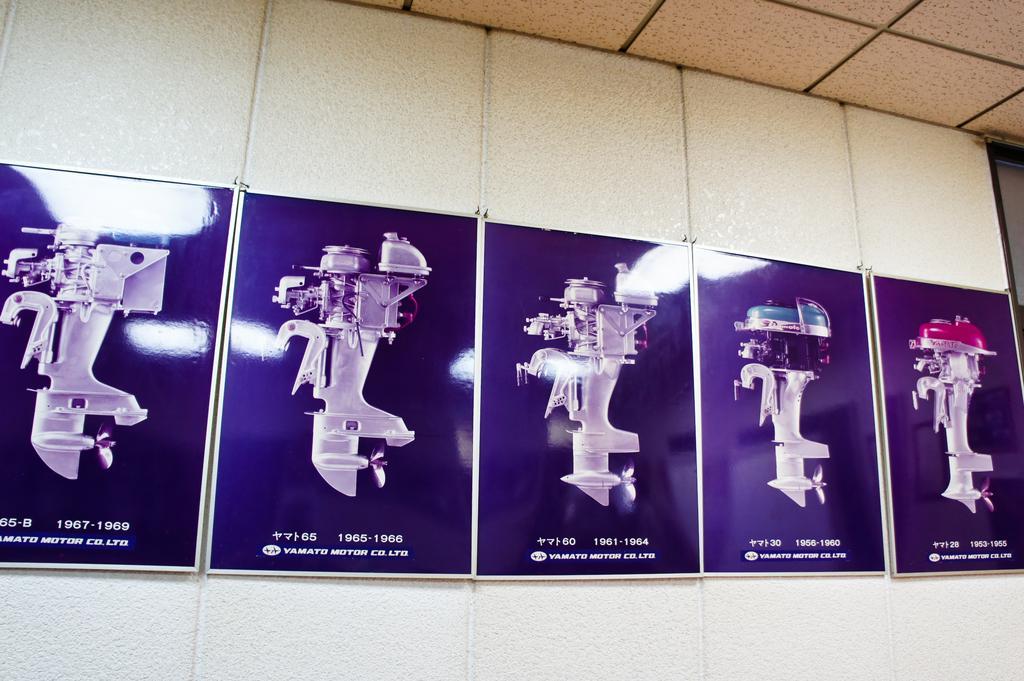Describe this image in one or two sentences. In the image there are photographs of machines on the wall. 